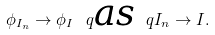<formula> <loc_0><loc_0><loc_500><loc_500>\phi _ { I _ { n } } \to \phi _ { I } \ q \text {\em as} \ q I _ { n } \to I .</formula> 